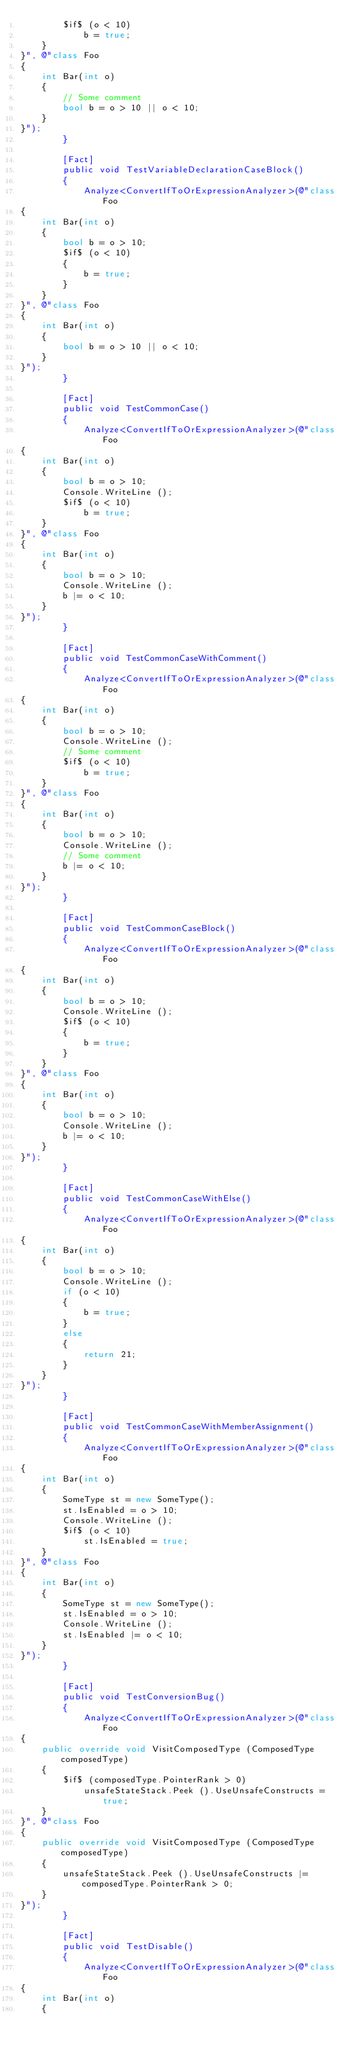Convert code to text. <code><loc_0><loc_0><loc_500><loc_500><_C#_>        $if$ (o < 10)
            b = true;
    }
}", @"class Foo
{
    int Bar(int o)
    {
        // Some comment
        bool b = o > 10 || o < 10;
    }
}");
        }

        [Fact]
        public void TestVariableDeclarationCaseBlock()
        {
            Analyze<ConvertIfToOrExpressionAnalyzer>(@"class Foo
{
    int Bar(int o)
    {
        bool b = o > 10;
        $if$ (o < 10)
        {
            b = true;
        }
    }
}", @"class Foo
{
    int Bar(int o)
    {
        bool b = o > 10 || o < 10;
    }
}");
        }

        [Fact]
        public void TestCommonCase()
        {
            Analyze<ConvertIfToOrExpressionAnalyzer>(@"class Foo
{
    int Bar(int o)
    {
        bool b = o > 10;
        Console.WriteLine ();
        $if$ (o < 10)
            b = true;
    }
}", @"class Foo
{
    int Bar(int o)
    {
        bool b = o > 10;
        Console.WriteLine ();
        b |= o < 10;
    }
}");
        }

        [Fact]
        public void TestCommonCaseWithComment()
        {
            Analyze<ConvertIfToOrExpressionAnalyzer>(@"class Foo
{
    int Bar(int o)
    {
        bool b = o > 10;
        Console.WriteLine ();
        // Some comment
        $if$ (o < 10)
            b = true;
    }
}", @"class Foo
{
    int Bar(int o)
    {
        bool b = o > 10;
        Console.WriteLine ();
        // Some comment
        b |= o < 10;
    }
}");
        }

        [Fact]
        public void TestCommonCaseBlock()
        {
            Analyze<ConvertIfToOrExpressionAnalyzer>(@"class Foo
{
    int Bar(int o)
    {
        bool b = o > 10;
        Console.WriteLine ();
        $if$ (o < 10)
        {
            b = true;
        }
    }
}", @"class Foo
{
    int Bar(int o)
    {
        bool b = o > 10;
        Console.WriteLine ();
        b |= o < 10;
    }
}");
        }

        [Fact]
        public void TestCommonCaseWithElse()
        {
            Analyze<ConvertIfToOrExpressionAnalyzer>(@"class Foo
{
    int Bar(int o)
    {
        bool b = o > 10;
        Console.WriteLine ();
        if (o < 10)
        {
            b = true;
        }
        else
        {
            return 21;
        }
    }
}");
        }

        [Fact]
        public void TestCommonCaseWithMemberAssignment()
        {
            Analyze<ConvertIfToOrExpressionAnalyzer>(@"class Foo
{
    int Bar(int o)
    {
        SomeType st = new SomeType();
        st.IsEnabled = o > 10;
        Console.WriteLine ();
        $if$ (o < 10)
            st.IsEnabled = true;
    }
}", @"class Foo
{
    int Bar(int o)
    {
        SomeType st = new SomeType();
        st.IsEnabled = o > 10;
        Console.WriteLine ();
        st.IsEnabled |= o < 10;
    }
}");
        }

        [Fact]
        public void TestConversionBug()
        {
            Analyze<ConvertIfToOrExpressionAnalyzer>(@"class Foo
{
    public override void VisitComposedType (ComposedType composedType)
    {
        $if$ (composedType.PointerRank > 0)
            unsafeStateStack.Peek ().UseUnsafeConstructs = true;
    }
}", @"class Foo
{
    public override void VisitComposedType (ComposedType composedType)
    {
        unsafeStateStack.Peek ().UseUnsafeConstructs |= composedType.PointerRank > 0;
    }
}");
        }

        [Fact]
        public void TestDisable()
        {
            Analyze<ConvertIfToOrExpressionAnalyzer>(@"class Foo
{
    int Bar(int o)
    {</code> 